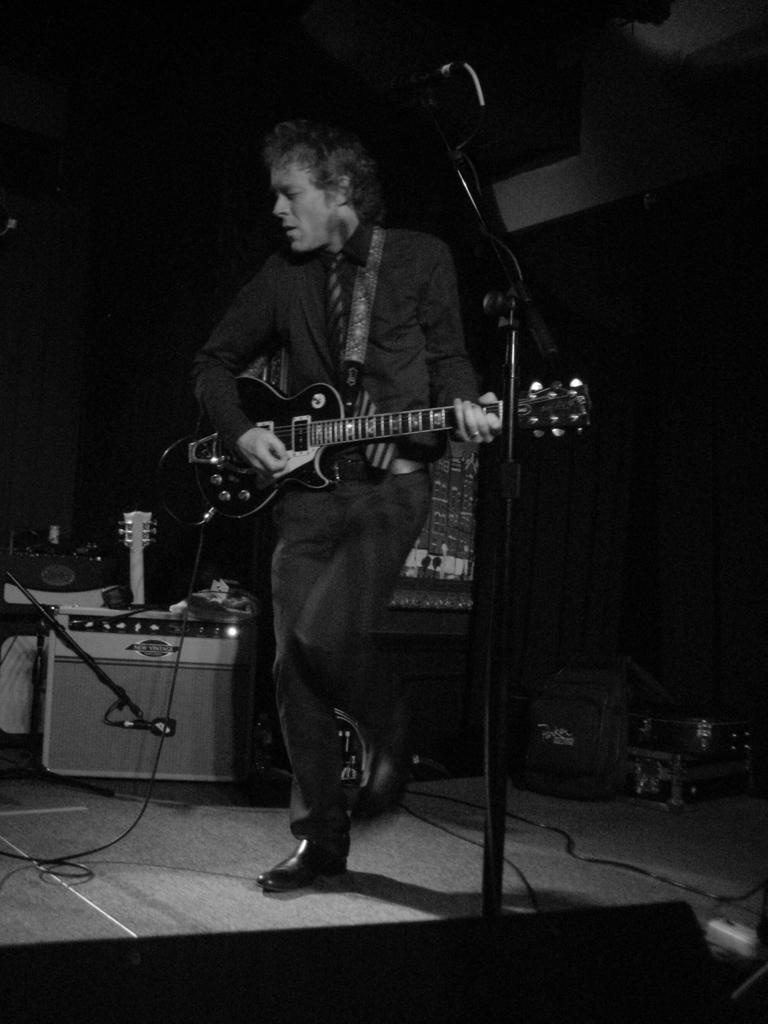What is the person in the image doing? The person is standing in the image and holding a guitar. What other objects related to music can be seen in the image? There is a microphone with a stand and other musical instruments present in the image. Can you describe any additional equipment or accessories in the image? Yes, there is a cable visible in the image. What type of surface is the person standing on? The image shows a floor. How many books can be seen on the person's digestion in the image? There are no books or references to digestion in the image; it focuses on a person holding a guitar and related music equipment. 